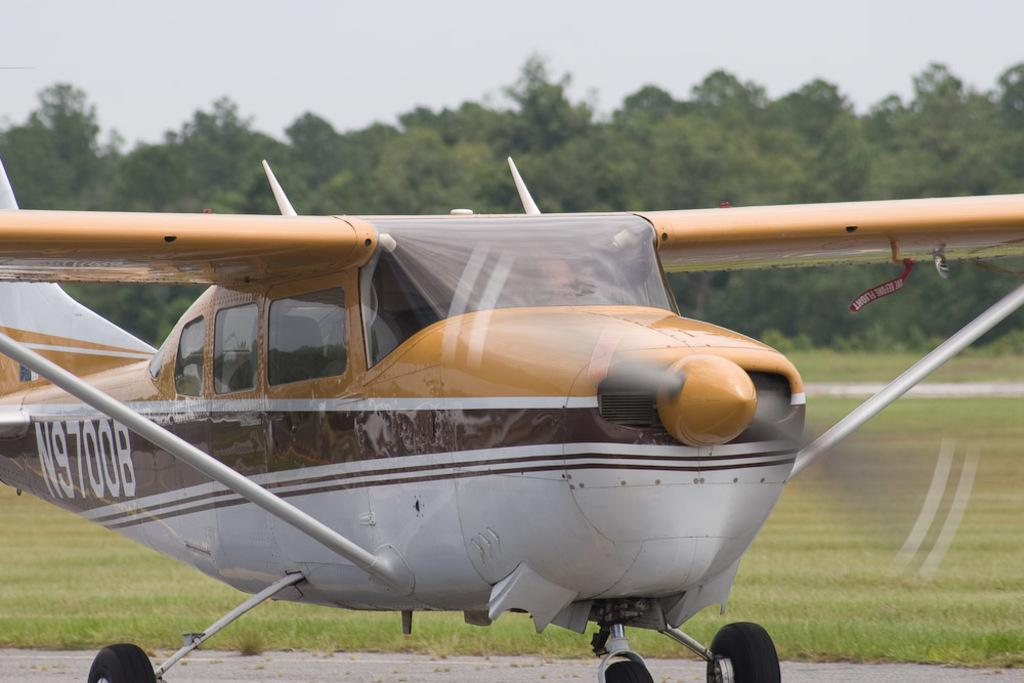Provide a one-sentence caption for the provided image. A plane has the numbers N9700B on the side. 